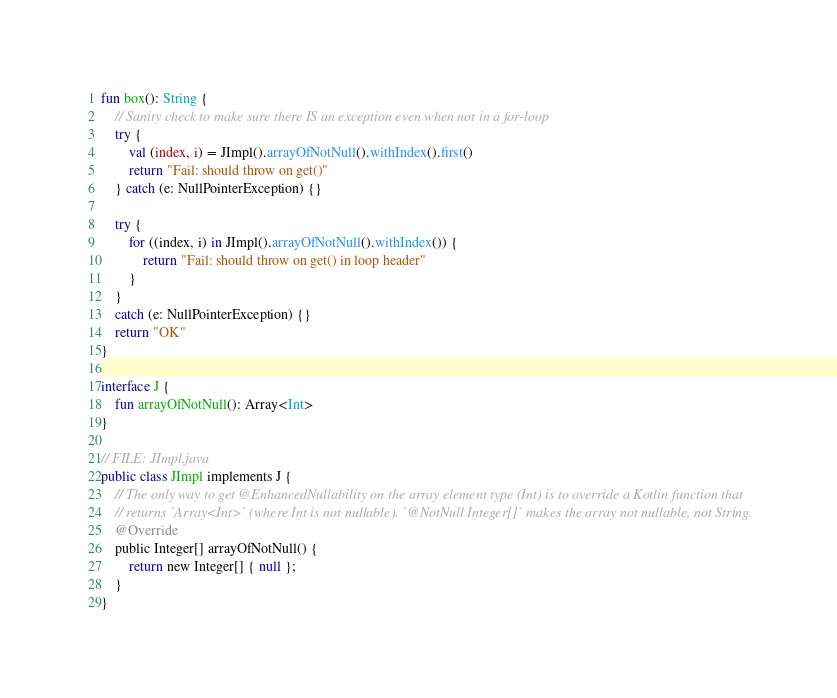<code> <loc_0><loc_0><loc_500><loc_500><_Kotlin_>
fun box(): String {
    // Sanity check to make sure there IS an exception even when not in a for-loop
    try {
        val (index, i) = JImpl().arrayOfNotNull().withIndex().first()
        return "Fail: should throw on get()"
    } catch (e: NullPointerException) {}

    try {
        for ((index, i) in JImpl().arrayOfNotNull().withIndex()) {
            return "Fail: should throw on get() in loop header"
        }
    }
    catch (e: NullPointerException) {}
    return "OK"
}

interface J {
    fun arrayOfNotNull(): Array<Int>
}

// FILE: JImpl.java
public class JImpl implements J {
    // The only way to get @EnhancedNullability on the array element type (Int) is to override a Kotlin function that
    // returns `Array<Int>` (where Int is not nullable). `@NotNull Integer[]` makes the array not nullable, not String.
    @Override
    public Integer[] arrayOfNotNull() {
        return new Integer[] { null };
    }
}
</code> 